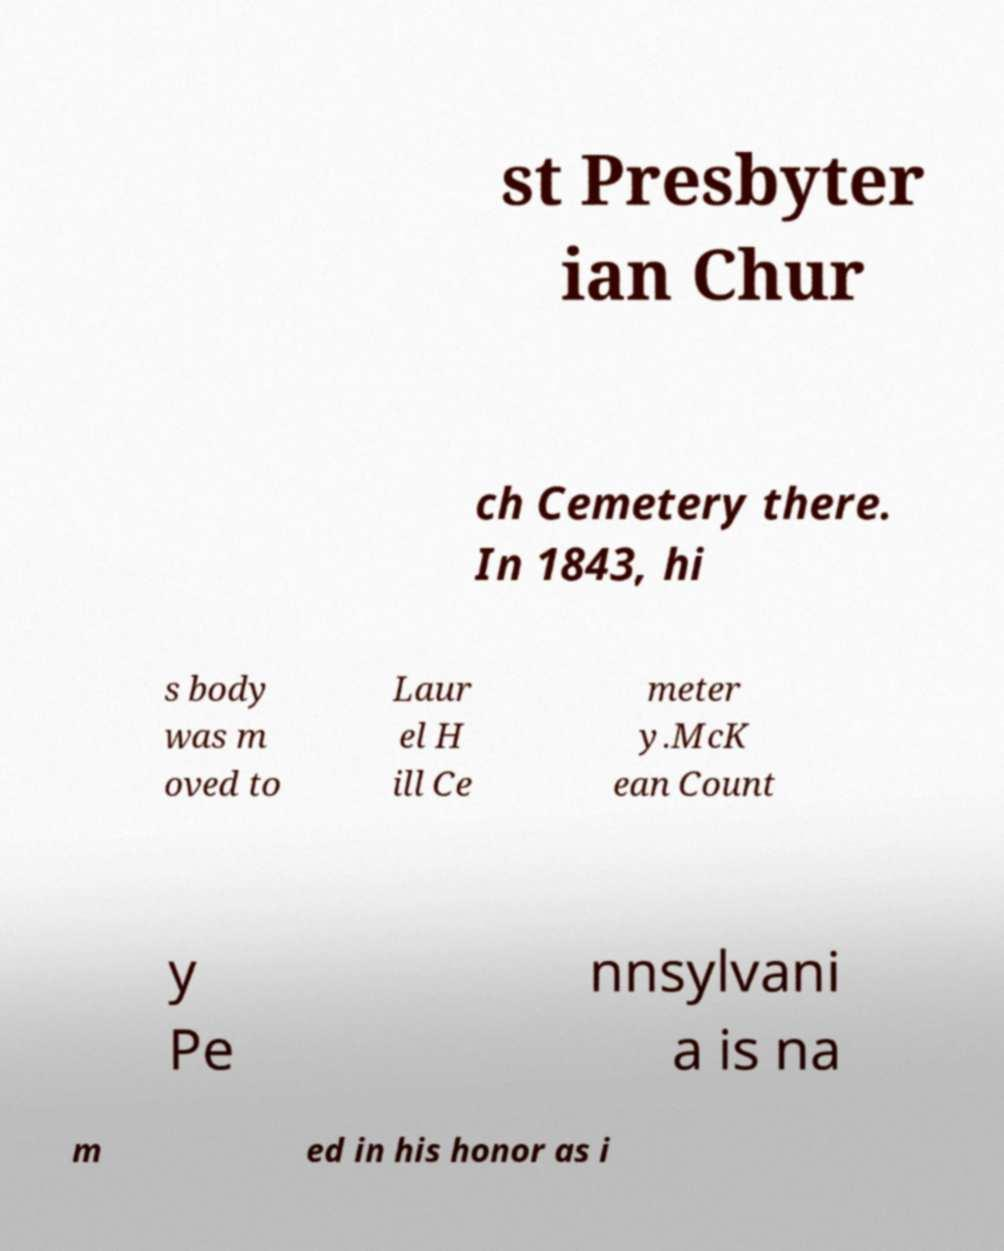Could you assist in decoding the text presented in this image and type it out clearly? st Presbyter ian Chur ch Cemetery there. In 1843, hi s body was m oved to Laur el H ill Ce meter y.McK ean Count y Pe nnsylvani a is na m ed in his honor as i 